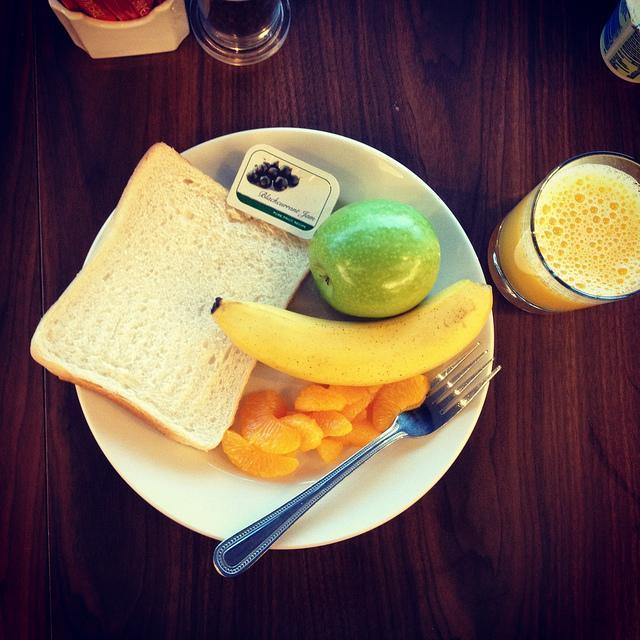How many apples are seen?
Give a very brief answer. 1. How many oranges are in the picture?
Give a very brief answer. 2. How many giraffes are there?
Give a very brief answer. 0. 